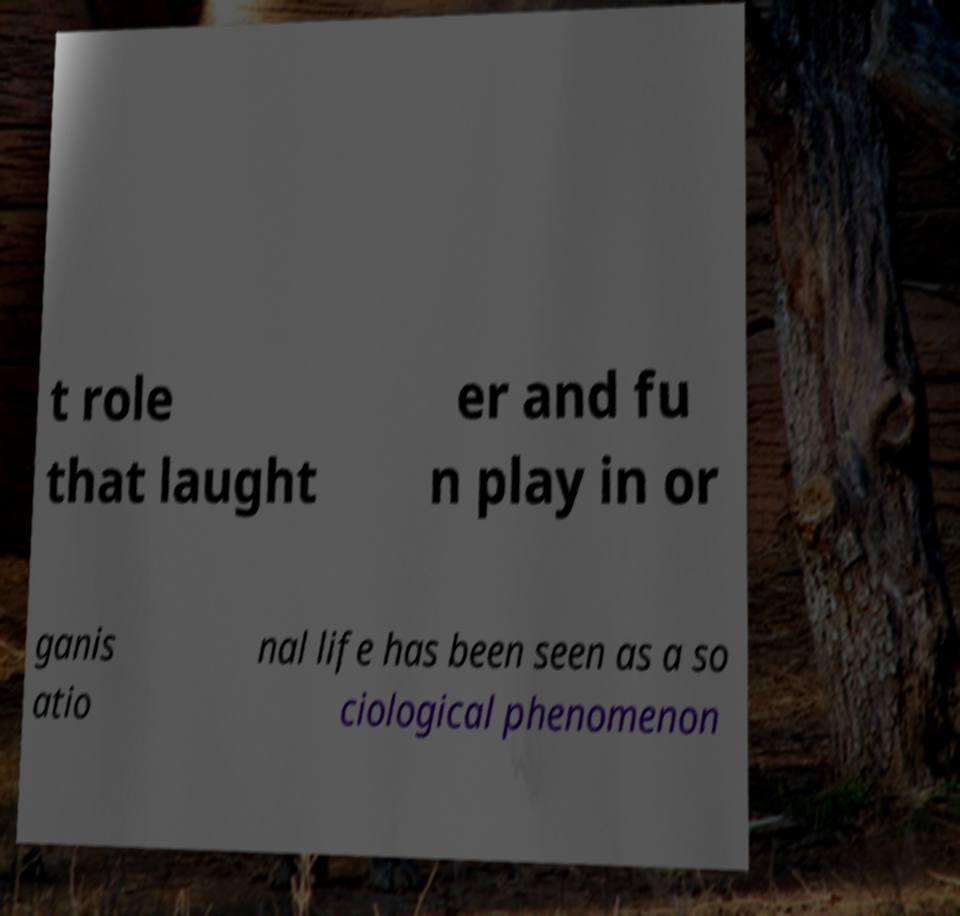For documentation purposes, I need the text within this image transcribed. Could you provide that? t role that laught er and fu n play in or ganis atio nal life has been seen as a so ciological phenomenon 